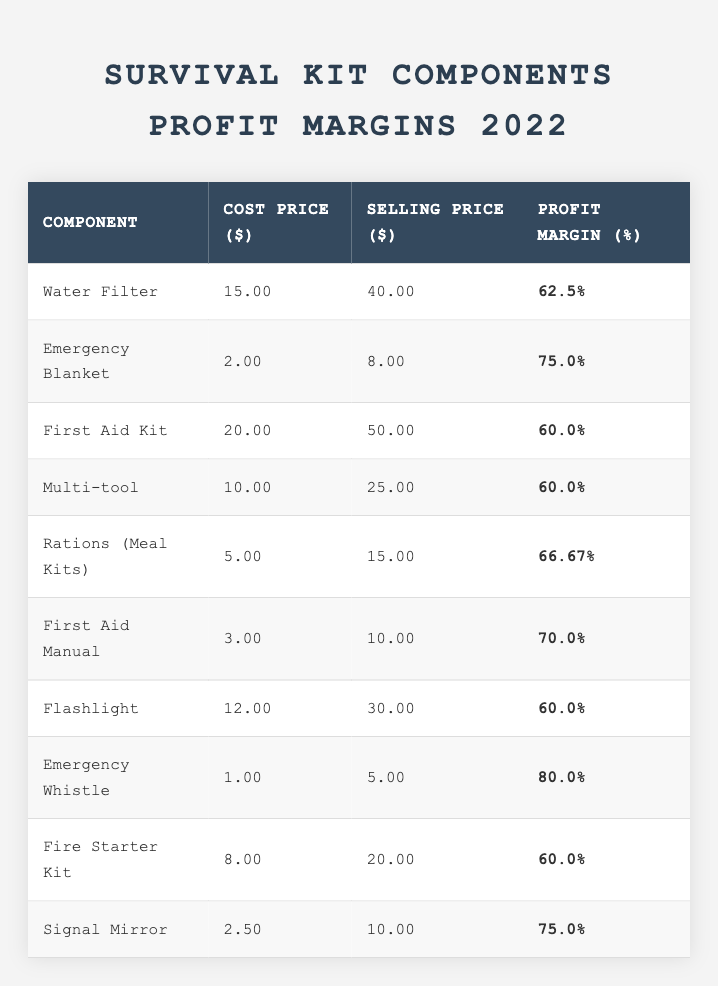What is the profit margin percentage of the Emergency Blanket? The table lists the profit margin percentage for each component. For the Emergency Blanket, it is displayed as 75.0%.
Answer: 75.0% Which survival kit component has the highest profit margin? By reviewing the profit margin percentages, the Emergency Whistle has the highest at 80.0%.
Answer: Emergency Whistle What is the selling price of the Fire Starter Kit? The selling price for the Fire Starter Kit is displayed in the corresponding row as $20.00.
Answer: $20.00 How much profit does the Water Filter generate per unit sold? The profit for each unit is calculated by subtracting the cost price from the selling price. For the Water Filter: $40.00 - $15.00 = $25.00 profit.
Answer: $25.00 What is the average profit margin percentage for all components listed? To find the average, we sum the profit margins: 62.5 + 75.0 + 60.0 + 60.0 + 66.67 + 70.0 + 60.0 + 80.0 + 60.0 + 75.0 =  690.17 and divide by the number of components, which is 10. Thus, the average is 690.17 / 10 = 69.02%.
Answer: 69.02% Is the profit margin of the Multi-tool greater than that of the First Aid Kit? The profit margin for Multi-tool is 60.0%, while for the First Aid Kit it's also 60.0%. Thus, they are equal and not greater.
Answer: No What is the difference in cost price between the most expensive and least expensive components? The most expensive component is the First Aid Kit at $20.00, and the least expensive is the Emergency Whistle at $1.00. The difference is $20.00 - $1.00 = $19.00.
Answer: $19.00 Can we identify a trend in profit margins based on the cost prices of the components? Upon examining the table, there is no clear trend indicating that lower cost prices necessarily lead to higher profit margins, as shown by the varied percentages across different cost levels.
Answer: No clear trend Which component gives the smallest profit margin and what is that margin? The component with the smallest profit margin is the Water Filter, with a margin of 62.5%.
Answer: 62.5% Does the First Aid Manual have a higher selling price than the Rations (Meal Kits)? The selling price for the First Aid Manual is $10.00, and for the Rations (Meal Kits), it is $15.00. Therefore, the First Aid Manual does not have a higher selling price.
Answer: No Which components have a profit margin above 70%? Components with a profit margin above 70% are the Emergency Blanket (75.0%), First Aid Manual (70.0%), and the Emergency Whistle (80.0%).
Answer: 3 components (Emergency Blanket, First Aid Manual, Emergency Whistle) 